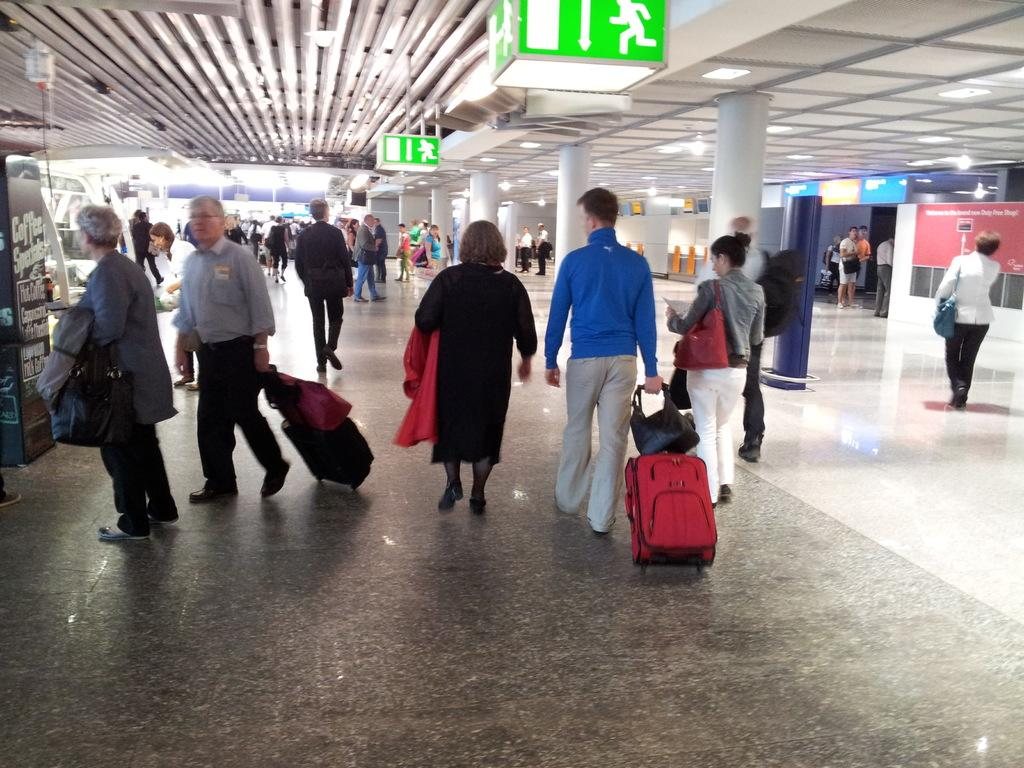What can be seen hanging in the image? There are banners in the image. What are the people in the image doing? The people in the image are walking. What type of coach can be seen in the image? There is no coach present in the image. What sound does the bell make in the image? There is no bell present in the image. 